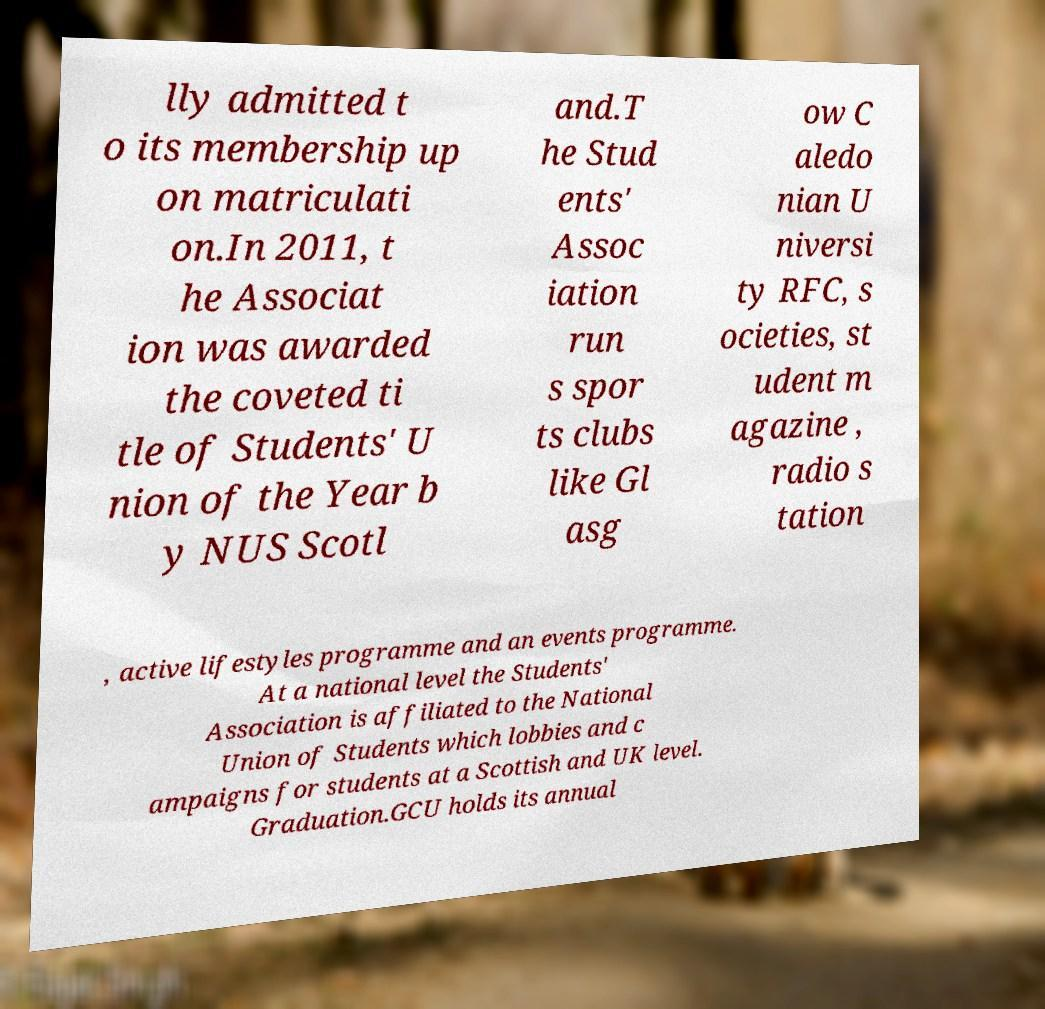There's text embedded in this image that I need extracted. Can you transcribe it verbatim? lly admitted t o its membership up on matriculati on.In 2011, t he Associat ion was awarded the coveted ti tle of Students' U nion of the Year b y NUS Scotl and.T he Stud ents' Assoc iation run s spor ts clubs like Gl asg ow C aledo nian U niversi ty RFC, s ocieties, st udent m agazine , radio s tation , active lifestyles programme and an events programme. At a national level the Students' Association is affiliated to the National Union of Students which lobbies and c ampaigns for students at a Scottish and UK level. Graduation.GCU holds its annual 